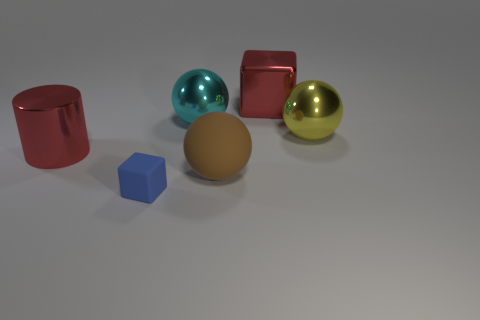Is there anything else that is the same size as the blue rubber object?
Make the answer very short. No. The rubber object in front of the big sphere that is in front of the big red metallic object to the left of the blue rubber cube is what shape?
Ensure brevity in your answer.  Cube. There is a cube to the right of the large cyan shiny ball; is it the same color as the large object to the left of the blue matte block?
Give a very brief answer. Yes. Is the number of large red metallic cubes that are in front of the small blue matte object less than the number of red things to the right of the big brown rubber thing?
Provide a short and direct response. Yes. There is another large rubber object that is the same shape as the yellow object; what is its color?
Offer a very short reply. Brown. There is a cyan thing; is its shape the same as the rubber object that is on the right side of the big cyan metal sphere?
Give a very brief answer. Yes. How many objects are either big things that are on the left side of the large cyan thing or big red shiny objects that are on the right side of the big brown rubber thing?
Keep it short and to the point. 2. What is the material of the large brown object?
Your response must be concise. Rubber. How many other objects are there of the same size as the blue thing?
Your answer should be compact. 0. What size is the ball right of the brown ball?
Offer a very short reply. Large. 